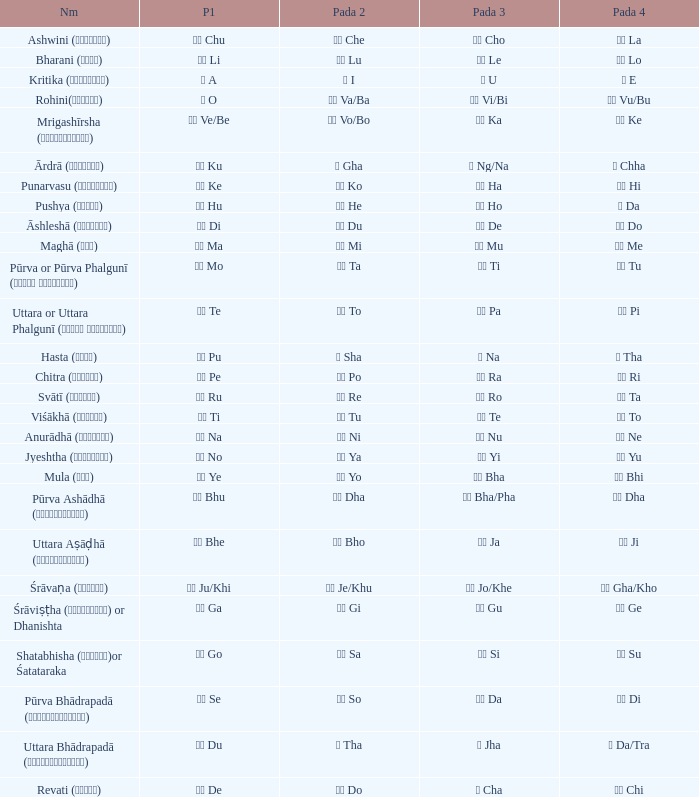What kind of Pada 4 has a Pada 1 of खी ju/khi? खो Gha/Kho. 